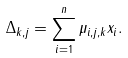Convert formula to latex. <formula><loc_0><loc_0><loc_500><loc_500>\Delta _ { k , j } = \sum _ { i = 1 } ^ { n } \mu _ { i , j , k } x _ { i } .</formula> 